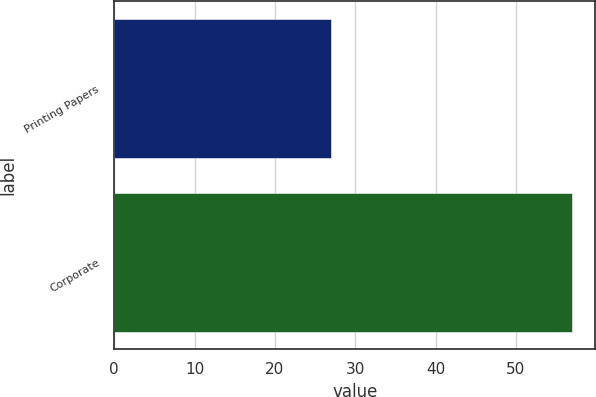Convert chart to OTSL. <chart><loc_0><loc_0><loc_500><loc_500><bar_chart><fcel>Printing Papers<fcel>Corporate<nl><fcel>27<fcel>57<nl></chart> 